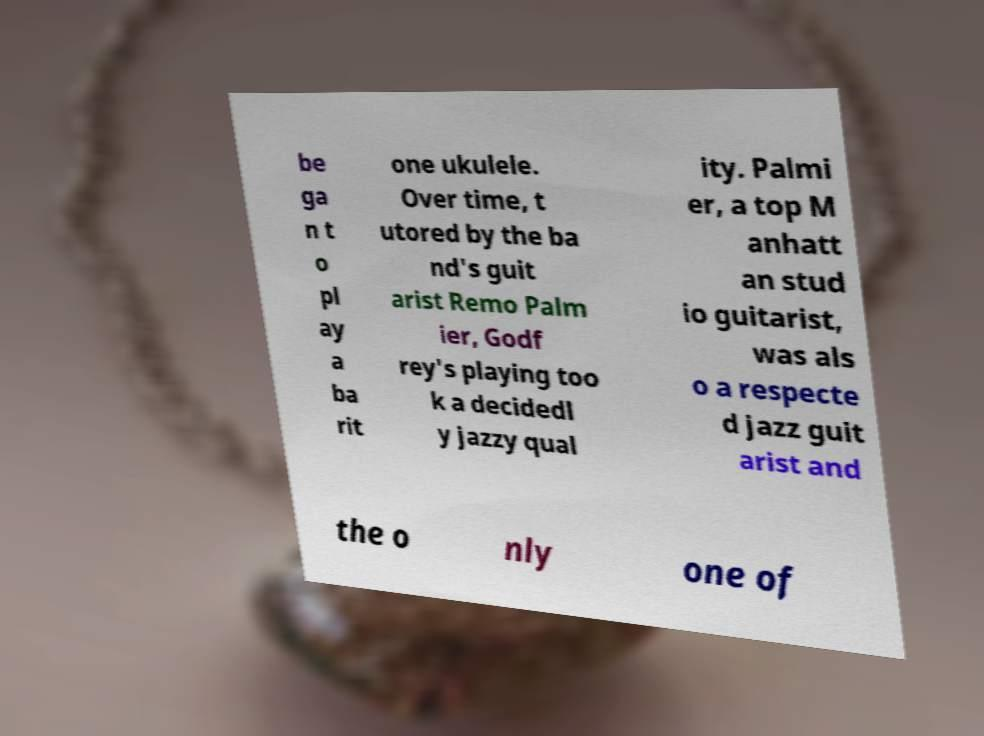Could you extract and type out the text from this image? be ga n t o pl ay a ba rit one ukulele. Over time, t utored by the ba nd's guit arist Remo Palm ier, Godf rey's playing too k a decidedl y jazzy qual ity. Palmi er, a top M anhatt an stud io guitarist, was als o a respecte d jazz guit arist and the o nly one of 